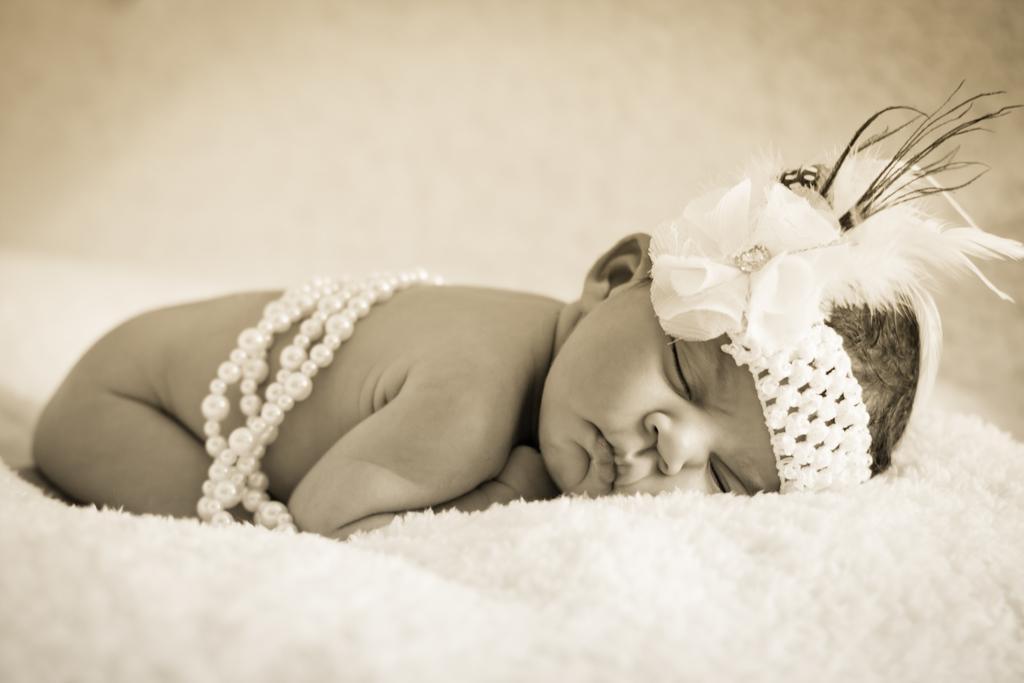How would you summarize this image in a sentence or two? This is a black and white image. In the middle of the image there is a baby laying on a white bed sheet. The background is blurred. 